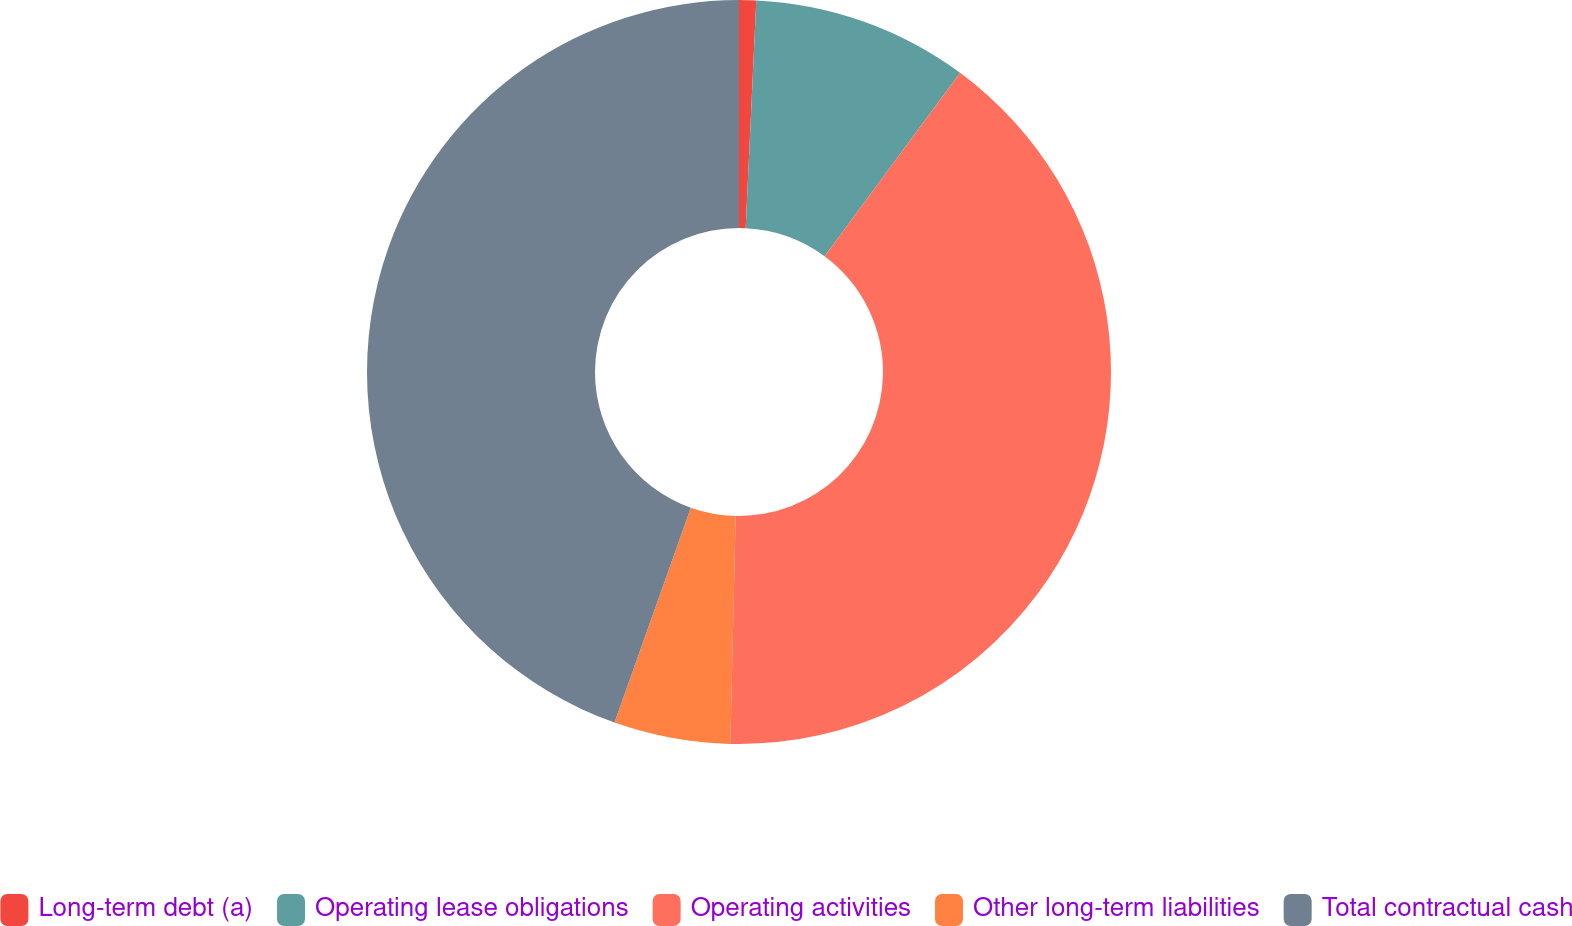<chart> <loc_0><loc_0><loc_500><loc_500><pie_chart><fcel>Long-term debt (a)<fcel>Operating lease obligations<fcel>Operating activities<fcel>Other long-term liabilities<fcel>Total contractual cash<nl><fcel>0.74%<fcel>9.39%<fcel>40.24%<fcel>5.06%<fcel>44.57%<nl></chart> 